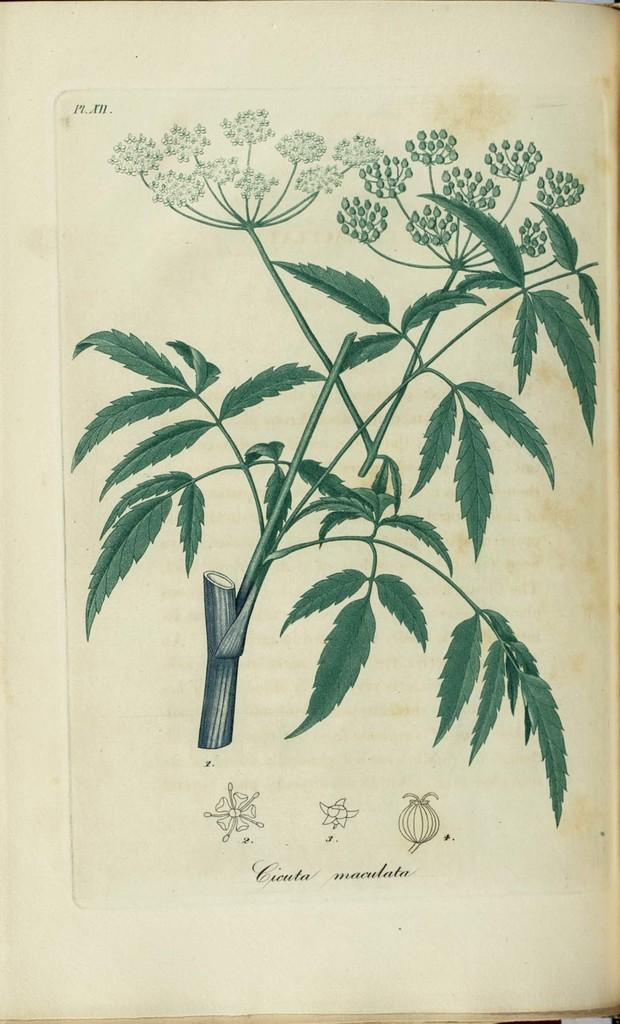What is depicted in the image? There is a painting of a plant in the image. Can you describe the subject of the painting? The painting depicts a plant. What thrilling event is taking place in the painting? There is no thrilling event depicted in the painting, as it features a static image of a plant. 